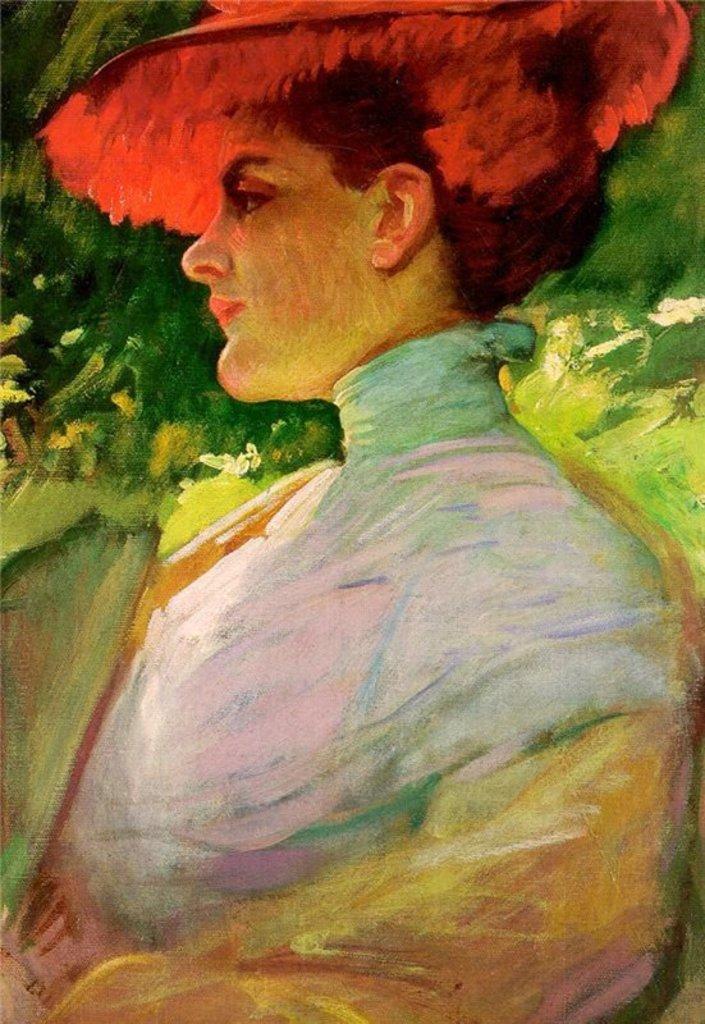In one or two sentences, can you explain what this image depicts? In this picture I can see there is a painting here and there is a woman in the painting and in the backdrop there are plants. 